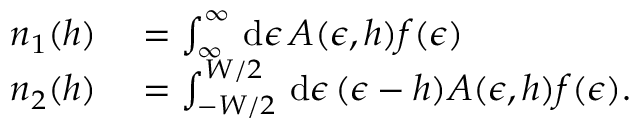Convert formula to latex. <formula><loc_0><loc_0><loc_500><loc_500>\begin{array} { r l } { n _ { 1 } ( h ) } & = \int _ { \infty } ^ { \infty } d \epsilon \, A ( \epsilon , h ) f ( \epsilon ) } \\ { n _ { 2 } ( h ) } & = \int _ { - W / 2 } ^ { W / 2 } d \epsilon \, ( \epsilon - h ) A ( \epsilon , h ) f ( \epsilon ) . } \end{array}</formula> 